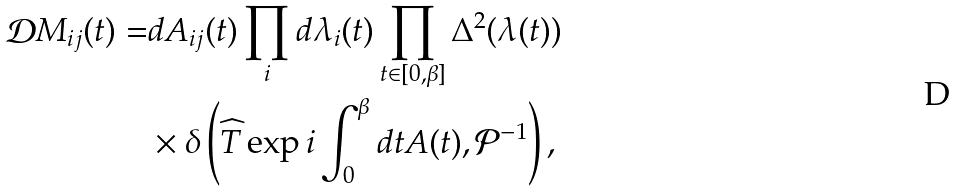Convert formula to latex. <formula><loc_0><loc_0><loc_500><loc_500>\mathcal { D } M _ { i j } ( t ) = & d A _ { i j } ( t ) \prod _ { i } d \lambda _ { i } ( t ) \prod _ { t \in [ 0 , \beta ] } \Delta ^ { 2 } ( \lambda ( t ) ) \\ & \times \delta \left ( \widehat { T } \exp i \int ^ { \beta } _ { 0 } d t A ( t ) , \mathcal { P } ^ { - 1 } \right ) ,</formula> 